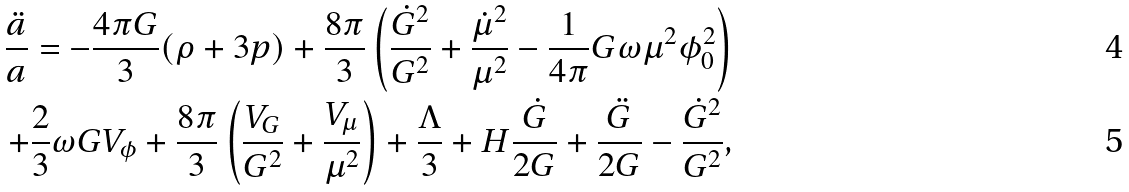Convert formula to latex. <formula><loc_0><loc_0><loc_500><loc_500>\frac { \ddot { a } } { a } = - \frac { 4 \pi G } { 3 } ( \rho + 3 p ) + \frac { 8 \pi } { 3 } \left ( \frac { \dot { G } ^ { 2 } } { G ^ { 2 } } + \frac { \dot { \mu } ^ { 2 } } { \mu ^ { 2 } } - \frac { 1 } { 4 \pi } G \omega \mu ^ { 2 } \phi _ { 0 } ^ { 2 } \right ) \\ + \frac { 2 } { 3 } \omega G V _ { \phi } + \frac { 8 \pi } { 3 } \left ( \frac { V _ { G } } { G ^ { 2 } } + \frac { V _ { \mu } } { \mu ^ { 2 } } \right ) + \frac { \Lambda } { 3 } + H \frac { \dot { G } } { 2 G } + \frac { \ddot { G } } { 2 G } - \frac { \dot { G } ^ { 2 } } { G ^ { 2 } } ,</formula> 